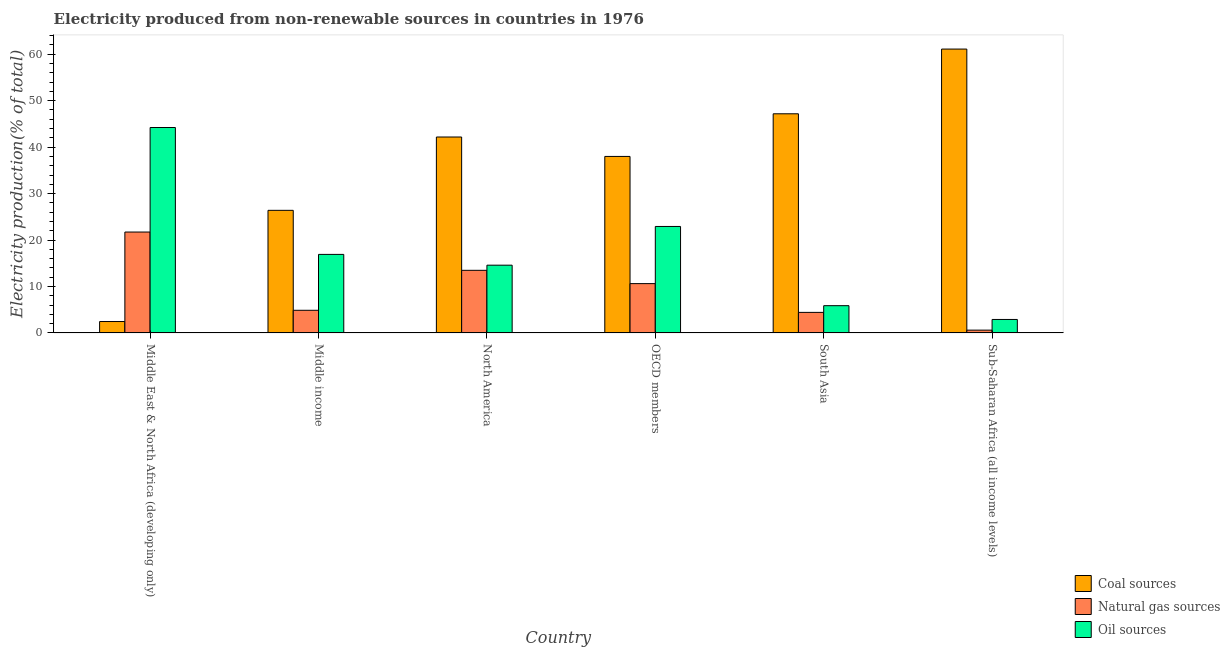How many different coloured bars are there?
Make the answer very short. 3. Are the number of bars on each tick of the X-axis equal?
Give a very brief answer. Yes. How many bars are there on the 5th tick from the right?
Your answer should be very brief. 3. What is the label of the 1st group of bars from the left?
Give a very brief answer. Middle East & North Africa (developing only). What is the percentage of electricity produced by coal in Middle East & North Africa (developing only)?
Give a very brief answer. 2.46. Across all countries, what is the maximum percentage of electricity produced by oil sources?
Your answer should be very brief. 44.23. Across all countries, what is the minimum percentage of electricity produced by natural gas?
Offer a terse response. 0.6. In which country was the percentage of electricity produced by natural gas maximum?
Ensure brevity in your answer.  Middle East & North Africa (developing only). In which country was the percentage of electricity produced by oil sources minimum?
Ensure brevity in your answer.  Sub-Saharan Africa (all income levels). What is the total percentage of electricity produced by oil sources in the graph?
Your answer should be compact. 107.42. What is the difference between the percentage of electricity produced by natural gas in OECD members and that in Sub-Saharan Africa (all income levels)?
Offer a very short reply. 10.01. What is the difference between the percentage of electricity produced by coal in South Asia and the percentage of electricity produced by natural gas in North America?
Provide a short and direct response. 33.7. What is the average percentage of electricity produced by oil sources per country?
Provide a succinct answer. 17.9. What is the difference between the percentage of electricity produced by oil sources and percentage of electricity produced by natural gas in South Asia?
Offer a terse response. 1.44. In how many countries, is the percentage of electricity produced by coal greater than 50 %?
Offer a very short reply. 1. What is the ratio of the percentage of electricity produced by coal in OECD members to that in Sub-Saharan Africa (all income levels)?
Make the answer very short. 0.62. Is the difference between the percentage of electricity produced by coal in North America and OECD members greater than the difference between the percentage of electricity produced by natural gas in North America and OECD members?
Your answer should be very brief. Yes. What is the difference between the highest and the second highest percentage of electricity produced by natural gas?
Your answer should be very brief. 8.24. What is the difference between the highest and the lowest percentage of electricity produced by natural gas?
Your response must be concise. 21.12. In how many countries, is the percentage of electricity produced by oil sources greater than the average percentage of electricity produced by oil sources taken over all countries?
Keep it short and to the point. 2. What does the 1st bar from the left in Sub-Saharan Africa (all income levels) represents?
Your answer should be very brief. Coal sources. What does the 1st bar from the right in North America represents?
Offer a very short reply. Oil sources. Is it the case that in every country, the sum of the percentage of electricity produced by coal and percentage of electricity produced by natural gas is greater than the percentage of electricity produced by oil sources?
Your answer should be compact. No. How many bars are there?
Offer a terse response. 18. What is the difference between two consecutive major ticks on the Y-axis?
Your answer should be very brief. 10. Are the values on the major ticks of Y-axis written in scientific E-notation?
Offer a terse response. No. Does the graph contain grids?
Your response must be concise. No. Where does the legend appear in the graph?
Give a very brief answer. Bottom right. What is the title of the graph?
Offer a terse response. Electricity produced from non-renewable sources in countries in 1976. What is the label or title of the X-axis?
Your response must be concise. Country. What is the Electricity production(% of total) of Coal sources in Middle East & North Africa (developing only)?
Your answer should be very brief. 2.46. What is the Electricity production(% of total) in Natural gas sources in Middle East & North Africa (developing only)?
Give a very brief answer. 21.72. What is the Electricity production(% of total) of Oil sources in Middle East & North Africa (developing only)?
Your answer should be very brief. 44.23. What is the Electricity production(% of total) of Coal sources in Middle income?
Keep it short and to the point. 26.39. What is the Electricity production(% of total) of Natural gas sources in Middle income?
Your response must be concise. 4.87. What is the Electricity production(% of total) in Oil sources in Middle income?
Your response must be concise. 16.91. What is the Electricity production(% of total) in Coal sources in North America?
Offer a very short reply. 42.18. What is the Electricity production(% of total) in Natural gas sources in North America?
Your answer should be very brief. 13.48. What is the Electricity production(% of total) of Oil sources in North America?
Offer a very short reply. 14.59. What is the Electricity production(% of total) of Coal sources in OECD members?
Keep it short and to the point. 38. What is the Electricity production(% of total) in Natural gas sources in OECD members?
Make the answer very short. 10.62. What is the Electricity production(% of total) of Oil sources in OECD members?
Your response must be concise. 22.92. What is the Electricity production(% of total) in Coal sources in South Asia?
Your answer should be very brief. 47.18. What is the Electricity production(% of total) in Natural gas sources in South Asia?
Provide a short and direct response. 4.43. What is the Electricity production(% of total) of Oil sources in South Asia?
Your answer should be compact. 5.87. What is the Electricity production(% of total) of Coal sources in Sub-Saharan Africa (all income levels)?
Your answer should be very brief. 61.11. What is the Electricity production(% of total) in Natural gas sources in Sub-Saharan Africa (all income levels)?
Offer a very short reply. 0.6. What is the Electricity production(% of total) in Oil sources in Sub-Saharan Africa (all income levels)?
Provide a short and direct response. 2.9. Across all countries, what is the maximum Electricity production(% of total) of Coal sources?
Offer a terse response. 61.11. Across all countries, what is the maximum Electricity production(% of total) of Natural gas sources?
Provide a succinct answer. 21.72. Across all countries, what is the maximum Electricity production(% of total) in Oil sources?
Ensure brevity in your answer.  44.23. Across all countries, what is the minimum Electricity production(% of total) in Coal sources?
Provide a short and direct response. 2.46. Across all countries, what is the minimum Electricity production(% of total) in Natural gas sources?
Offer a terse response. 0.6. Across all countries, what is the minimum Electricity production(% of total) of Oil sources?
Provide a short and direct response. 2.9. What is the total Electricity production(% of total) of Coal sources in the graph?
Offer a terse response. 217.32. What is the total Electricity production(% of total) of Natural gas sources in the graph?
Provide a succinct answer. 55.72. What is the total Electricity production(% of total) in Oil sources in the graph?
Your response must be concise. 107.42. What is the difference between the Electricity production(% of total) of Coal sources in Middle East & North Africa (developing only) and that in Middle income?
Ensure brevity in your answer.  -23.94. What is the difference between the Electricity production(% of total) of Natural gas sources in Middle East & North Africa (developing only) and that in Middle income?
Keep it short and to the point. 16.85. What is the difference between the Electricity production(% of total) in Oil sources in Middle East & North Africa (developing only) and that in Middle income?
Keep it short and to the point. 27.32. What is the difference between the Electricity production(% of total) of Coal sources in Middle East & North Africa (developing only) and that in North America?
Keep it short and to the point. -39.72. What is the difference between the Electricity production(% of total) in Natural gas sources in Middle East & North Africa (developing only) and that in North America?
Give a very brief answer. 8.24. What is the difference between the Electricity production(% of total) in Oil sources in Middle East & North Africa (developing only) and that in North America?
Offer a terse response. 29.64. What is the difference between the Electricity production(% of total) in Coal sources in Middle East & North Africa (developing only) and that in OECD members?
Offer a terse response. -35.54. What is the difference between the Electricity production(% of total) in Natural gas sources in Middle East & North Africa (developing only) and that in OECD members?
Make the answer very short. 11.1. What is the difference between the Electricity production(% of total) in Oil sources in Middle East & North Africa (developing only) and that in OECD members?
Your answer should be very brief. 21.3. What is the difference between the Electricity production(% of total) of Coal sources in Middle East & North Africa (developing only) and that in South Asia?
Offer a terse response. -44.72. What is the difference between the Electricity production(% of total) of Natural gas sources in Middle East & North Africa (developing only) and that in South Asia?
Your answer should be very brief. 17.3. What is the difference between the Electricity production(% of total) of Oil sources in Middle East & North Africa (developing only) and that in South Asia?
Your answer should be very brief. 38.36. What is the difference between the Electricity production(% of total) of Coal sources in Middle East & North Africa (developing only) and that in Sub-Saharan Africa (all income levels)?
Keep it short and to the point. -58.65. What is the difference between the Electricity production(% of total) in Natural gas sources in Middle East & North Africa (developing only) and that in Sub-Saharan Africa (all income levels)?
Provide a short and direct response. 21.12. What is the difference between the Electricity production(% of total) of Oil sources in Middle East & North Africa (developing only) and that in Sub-Saharan Africa (all income levels)?
Offer a terse response. 41.32. What is the difference between the Electricity production(% of total) in Coal sources in Middle income and that in North America?
Your answer should be compact. -15.79. What is the difference between the Electricity production(% of total) in Natural gas sources in Middle income and that in North America?
Your response must be concise. -8.61. What is the difference between the Electricity production(% of total) of Oil sources in Middle income and that in North America?
Ensure brevity in your answer.  2.32. What is the difference between the Electricity production(% of total) of Coal sources in Middle income and that in OECD members?
Provide a short and direct response. -11.6. What is the difference between the Electricity production(% of total) of Natural gas sources in Middle income and that in OECD members?
Provide a short and direct response. -5.74. What is the difference between the Electricity production(% of total) of Oil sources in Middle income and that in OECD members?
Your response must be concise. -6.01. What is the difference between the Electricity production(% of total) of Coal sources in Middle income and that in South Asia?
Offer a very short reply. -20.78. What is the difference between the Electricity production(% of total) in Natural gas sources in Middle income and that in South Asia?
Provide a short and direct response. 0.45. What is the difference between the Electricity production(% of total) of Oil sources in Middle income and that in South Asia?
Offer a terse response. 11.04. What is the difference between the Electricity production(% of total) in Coal sources in Middle income and that in Sub-Saharan Africa (all income levels)?
Give a very brief answer. -34.72. What is the difference between the Electricity production(% of total) of Natural gas sources in Middle income and that in Sub-Saharan Africa (all income levels)?
Offer a terse response. 4.27. What is the difference between the Electricity production(% of total) in Oil sources in Middle income and that in Sub-Saharan Africa (all income levels)?
Keep it short and to the point. 14.01. What is the difference between the Electricity production(% of total) in Coal sources in North America and that in OECD members?
Your response must be concise. 4.18. What is the difference between the Electricity production(% of total) in Natural gas sources in North America and that in OECD members?
Your response must be concise. 2.86. What is the difference between the Electricity production(% of total) in Oil sources in North America and that in OECD members?
Your answer should be very brief. -8.33. What is the difference between the Electricity production(% of total) in Coal sources in North America and that in South Asia?
Provide a short and direct response. -5. What is the difference between the Electricity production(% of total) of Natural gas sources in North America and that in South Asia?
Your response must be concise. 9.06. What is the difference between the Electricity production(% of total) in Oil sources in North America and that in South Asia?
Offer a very short reply. 8.72. What is the difference between the Electricity production(% of total) in Coal sources in North America and that in Sub-Saharan Africa (all income levels)?
Provide a succinct answer. -18.93. What is the difference between the Electricity production(% of total) of Natural gas sources in North America and that in Sub-Saharan Africa (all income levels)?
Your answer should be very brief. 12.88. What is the difference between the Electricity production(% of total) in Oil sources in North America and that in Sub-Saharan Africa (all income levels)?
Provide a succinct answer. 11.69. What is the difference between the Electricity production(% of total) of Coal sources in OECD members and that in South Asia?
Keep it short and to the point. -9.18. What is the difference between the Electricity production(% of total) of Natural gas sources in OECD members and that in South Asia?
Offer a terse response. 6.19. What is the difference between the Electricity production(% of total) of Oil sources in OECD members and that in South Asia?
Ensure brevity in your answer.  17.05. What is the difference between the Electricity production(% of total) of Coal sources in OECD members and that in Sub-Saharan Africa (all income levels)?
Offer a terse response. -23.11. What is the difference between the Electricity production(% of total) in Natural gas sources in OECD members and that in Sub-Saharan Africa (all income levels)?
Make the answer very short. 10.01. What is the difference between the Electricity production(% of total) of Oil sources in OECD members and that in Sub-Saharan Africa (all income levels)?
Provide a succinct answer. 20.02. What is the difference between the Electricity production(% of total) in Coal sources in South Asia and that in Sub-Saharan Africa (all income levels)?
Keep it short and to the point. -13.93. What is the difference between the Electricity production(% of total) of Natural gas sources in South Asia and that in Sub-Saharan Africa (all income levels)?
Your answer should be very brief. 3.82. What is the difference between the Electricity production(% of total) of Oil sources in South Asia and that in Sub-Saharan Africa (all income levels)?
Offer a very short reply. 2.97. What is the difference between the Electricity production(% of total) of Coal sources in Middle East & North Africa (developing only) and the Electricity production(% of total) of Natural gas sources in Middle income?
Provide a short and direct response. -2.42. What is the difference between the Electricity production(% of total) in Coal sources in Middle East & North Africa (developing only) and the Electricity production(% of total) in Oil sources in Middle income?
Your response must be concise. -14.45. What is the difference between the Electricity production(% of total) of Natural gas sources in Middle East & North Africa (developing only) and the Electricity production(% of total) of Oil sources in Middle income?
Your response must be concise. 4.81. What is the difference between the Electricity production(% of total) in Coal sources in Middle East & North Africa (developing only) and the Electricity production(% of total) in Natural gas sources in North America?
Your response must be concise. -11.02. What is the difference between the Electricity production(% of total) of Coal sources in Middle East & North Africa (developing only) and the Electricity production(% of total) of Oil sources in North America?
Provide a short and direct response. -12.13. What is the difference between the Electricity production(% of total) in Natural gas sources in Middle East & North Africa (developing only) and the Electricity production(% of total) in Oil sources in North America?
Provide a short and direct response. 7.13. What is the difference between the Electricity production(% of total) in Coal sources in Middle East & North Africa (developing only) and the Electricity production(% of total) in Natural gas sources in OECD members?
Offer a terse response. -8.16. What is the difference between the Electricity production(% of total) in Coal sources in Middle East & North Africa (developing only) and the Electricity production(% of total) in Oil sources in OECD members?
Your response must be concise. -20.47. What is the difference between the Electricity production(% of total) of Natural gas sources in Middle East & North Africa (developing only) and the Electricity production(% of total) of Oil sources in OECD members?
Your answer should be very brief. -1.2. What is the difference between the Electricity production(% of total) in Coal sources in Middle East & North Africa (developing only) and the Electricity production(% of total) in Natural gas sources in South Asia?
Provide a succinct answer. -1.97. What is the difference between the Electricity production(% of total) of Coal sources in Middle East & North Africa (developing only) and the Electricity production(% of total) of Oil sources in South Asia?
Your answer should be very brief. -3.41. What is the difference between the Electricity production(% of total) of Natural gas sources in Middle East & North Africa (developing only) and the Electricity production(% of total) of Oil sources in South Asia?
Your response must be concise. 15.85. What is the difference between the Electricity production(% of total) of Coal sources in Middle East & North Africa (developing only) and the Electricity production(% of total) of Natural gas sources in Sub-Saharan Africa (all income levels)?
Ensure brevity in your answer.  1.85. What is the difference between the Electricity production(% of total) of Coal sources in Middle East & North Africa (developing only) and the Electricity production(% of total) of Oil sources in Sub-Saharan Africa (all income levels)?
Offer a terse response. -0.45. What is the difference between the Electricity production(% of total) of Natural gas sources in Middle East & North Africa (developing only) and the Electricity production(% of total) of Oil sources in Sub-Saharan Africa (all income levels)?
Your response must be concise. 18.82. What is the difference between the Electricity production(% of total) of Coal sources in Middle income and the Electricity production(% of total) of Natural gas sources in North America?
Make the answer very short. 12.91. What is the difference between the Electricity production(% of total) of Coal sources in Middle income and the Electricity production(% of total) of Oil sources in North America?
Keep it short and to the point. 11.81. What is the difference between the Electricity production(% of total) in Natural gas sources in Middle income and the Electricity production(% of total) in Oil sources in North America?
Provide a succinct answer. -9.71. What is the difference between the Electricity production(% of total) in Coal sources in Middle income and the Electricity production(% of total) in Natural gas sources in OECD members?
Provide a succinct answer. 15.78. What is the difference between the Electricity production(% of total) of Coal sources in Middle income and the Electricity production(% of total) of Oil sources in OECD members?
Provide a succinct answer. 3.47. What is the difference between the Electricity production(% of total) in Natural gas sources in Middle income and the Electricity production(% of total) in Oil sources in OECD members?
Offer a very short reply. -18.05. What is the difference between the Electricity production(% of total) of Coal sources in Middle income and the Electricity production(% of total) of Natural gas sources in South Asia?
Give a very brief answer. 21.97. What is the difference between the Electricity production(% of total) of Coal sources in Middle income and the Electricity production(% of total) of Oil sources in South Asia?
Your answer should be compact. 20.53. What is the difference between the Electricity production(% of total) in Natural gas sources in Middle income and the Electricity production(% of total) in Oil sources in South Asia?
Provide a short and direct response. -0.99. What is the difference between the Electricity production(% of total) of Coal sources in Middle income and the Electricity production(% of total) of Natural gas sources in Sub-Saharan Africa (all income levels)?
Provide a short and direct response. 25.79. What is the difference between the Electricity production(% of total) in Coal sources in Middle income and the Electricity production(% of total) in Oil sources in Sub-Saharan Africa (all income levels)?
Keep it short and to the point. 23.49. What is the difference between the Electricity production(% of total) in Natural gas sources in Middle income and the Electricity production(% of total) in Oil sources in Sub-Saharan Africa (all income levels)?
Ensure brevity in your answer.  1.97. What is the difference between the Electricity production(% of total) in Coal sources in North America and the Electricity production(% of total) in Natural gas sources in OECD members?
Provide a succinct answer. 31.56. What is the difference between the Electricity production(% of total) of Coal sources in North America and the Electricity production(% of total) of Oil sources in OECD members?
Offer a terse response. 19.26. What is the difference between the Electricity production(% of total) in Natural gas sources in North America and the Electricity production(% of total) in Oil sources in OECD members?
Provide a succinct answer. -9.44. What is the difference between the Electricity production(% of total) in Coal sources in North America and the Electricity production(% of total) in Natural gas sources in South Asia?
Your response must be concise. 37.76. What is the difference between the Electricity production(% of total) in Coal sources in North America and the Electricity production(% of total) in Oil sources in South Asia?
Offer a very short reply. 36.31. What is the difference between the Electricity production(% of total) of Natural gas sources in North America and the Electricity production(% of total) of Oil sources in South Asia?
Ensure brevity in your answer.  7.61. What is the difference between the Electricity production(% of total) of Coal sources in North America and the Electricity production(% of total) of Natural gas sources in Sub-Saharan Africa (all income levels)?
Make the answer very short. 41.58. What is the difference between the Electricity production(% of total) of Coal sources in North America and the Electricity production(% of total) of Oil sources in Sub-Saharan Africa (all income levels)?
Make the answer very short. 39.28. What is the difference between the Electricity production(% of total) of Natural gas sources in North America and the Electricity production(% of total) of Oil sources in Sub-Saharan Africa (all income levels)?
Offer a terse response. 10.58. What is the difference between the Electricity production(% of total) in Coal sources in OECD members and the Electricity production(% of total) in Natural gas sources in South Asia?
Offer a terse response. 33.57. What is the difference between the Electricity production(% of total) of Coal sources in OECD members and the Electricity production(% of total) of Oil sources in South Asia?
Give a very brief answer. 32.13. What is the difference between the Electricity production(% of total) in Natural gas sources in OECD members and the Electricity production(% of total) in Oil sources in South Asia?
Your answer should be compact. 4.75. What is the difference between the Electricity production(% of total) of Coal sources in OECD members and the Electricity production(% of total) of Natural gas sources in Sub-Saharan Africa (all income levels)?
Your response must be concise. 37.39. What is the difference between the Electricity production(% of total) in Coal sources in OECD members and the Electricity production(% of total) in Oil sources in Sub-Saharan Africa (all income levels)?
Your answer should be compact. 35.09. What is the difference between the Electricity production(% of total) of Natural gas sources in OECD members and the Electricity production(% of total) of Oil sources in Sub-Saharan Africa (all income levels)?
Give a very brief answer. 7.71. What is the difference between the Electricity production(% of total) of Coal sources in South Asia and the Electricity production(% of total) of Natural gas sources in Sub-Saharan Africa (all income levels)?
Make the answer very short. 46.57. What is the difference between the Electricity production(% of total) in Coal sources in South Asia and the Electricity production(% of total) in Oil sources in Sub-Saharan Africa (all income levels)?
Give a very brief answer. 44.27. What is the difference between the Electricity production(% of total) in Natural gas sources in South Asia and the Electricity production(% of total) in Oil sources in Sub-Saharan Africa (all income levels)?
Provide a short and direct response. 1.52. What is the average Electricity production(% of total) in Coal sources per country?
Make the answer very short. 36.22. What is the average Electricity production(% of total) of Natural gas sources per country?
Offer a terse response. 9.29. What is the average Electricity production(% of total) in Oil sources per country?
Your answer should be compact. 17.9. What is the difference between the Electricity production(% of total) in Coal sources and Electricity production(% of total) in Natural gas sources in Middle East & North Africa (developing only)?
Give a very brief answer. -19.26. What is the difference between the Electricity production(% of total) in Coal sources and Electricity production(% of total) in Oil sources in Middle East & North Africa (developing only)?
Offer a very short reply. -41.77. What is the difference between the Electricity production(% of total) in Natural gas sources and Electricity production(% of total) in Oil sources in Middle East & North Africa (developing only)?
Keep it short and to the point. -22.5. What is the difference between the Electricity production(% of total) of Coal sources and Electricity production(% of total) of Natural gas sources in Middle income?
Your answer should be compact. 21.52. What is the difference between the Electricity production(% of total) in Coal sources and Electricity production(% of total) in Oil sources in Middle income?
Give a very brief answer. 9.49. What is the difference between the Electricity production(% of total) of Natural gas sources and Electricity production(% of total) of Oil sources in Middle income?
Keep it short and to the point. -12.03. What is the difference between the Electricity production(% of total) in Coal sources and Electricity production(% of total) in Natural gas sources in North America?
Provide a succinct answer. 28.7. What is the difference between the Electricity production(% of total) in Coal sources and Electricity production(% of total) in Oil sources in North America?
Make the answer very short. 27.59. What is the difference between the Electricity production(% of total) of Natural gas sources and Electricity production(% of total) of Oil sources in North America?
Provide a short and direct response. -1.11. What is the difference between the Electricity production(% of total) in Coal sources and Electricity production(% of total) in Natural gas sources in OECD members?
Offer a very short reply. 27.38. What is the difference between the Electricity production(% of total) in Coal sources and Electricity production(% of total) in Oil sources in OECD members?
Your answer should be compact. 15.07. What is the difference between the Electricity production(% of total) of Natural gas sources and Electricity production(% of total) of Oil sources in OECD members?
Your answer should be very brief. -12.31. What is the difference between the Electricity production(% of total) in Coal sources and Electricity production(% of total) in Natural gas sources in South Asia?
Offer a very short reply. 42.75. What is the difference between the Electricity production(% of total) of Coal sources and Electricity production(% of total) of Oil sources in South Asia?
Provide a succinct answer. 41.31. What is the difference between the Electricity production(% of total) in Natural gas sources and Electricity production(% of total) in Oil sources in South Asia?
Your answer should be compact. -1.44. What is the difference between the Electricity production(% of total) of Coal sources and Electricity production(% of total) of Natural gas sources in Sub-Saharan Africa (all income levels)?
Your answer should be very brief. 60.51. What is the difference between the Electricity production(% of total) of Coal sources and Electricity production(% of total) of Oil sources in Sub-Saharan Africa (all income levels)?
Give a very brief answer. 58.21. What is the difference between the Electricity production(% of total) of Natural gas sources and Electricity production(% of total) of Oil sources in Sub-Saharan Africa (all income levels)?
Your answer should be compact. -2.3. What is the ratio of the Electricity production(% of total) of Coal sources in Middle East & North Africa (developing only) to that in Middle income?
Your response must be concise. 0.09. What is the ratio of the Electricity production(% of total) in Natural gas sources in Middle East & North Africa (developing only) to that in Middle income?
Your answer should be compact. 4.46. What is the ratio of the Electricity production(% of total) of Oil sources in Middle East & North Africa (developing only) to that in Middle income?
Your response must be concise. 2.62. What is the ratio of the Electricity production(% of total) of Coal sources in Middle East & North Africa (developing only) to that in North America?
Ensure brevity in your answer.  0.06. What is the ratio of the Electricity production(% of total) in Natural gas sources in Middle East & North Africa (developing only) to that in North America?
Your response must be concise. 1.61. What is the ratio of the Electricity production(% of total) in Oil sources in Middle East & North Africa (developing only) to that in North America?
Your answer should be compact. 3.03. What is the ratio of the Electricity production(% of total) of Coal sources in Middle East & North Africa (developing only) to that in OECD members?
Make the answer very short. 0.06. What is the ratio of the Electricity production(% of total) in Natural gas sources in Middle East & North Africa (developing only) to that in OECD members?
Provide a short and direct response. 2.05. What is the ratio of the Electricity production(% of total) in Oil sources in Middle East & North Africa (developing only) to that in OECD members?
Give a very brief answer. 1.93. What is the ratio of the Electricity production(% of total) of Coal sources in Middle East & North Africa (developing only) to that in South Asia?
Your answer should be compact. 0.05. What is the ratio of the Electricity production(% of total) in Natural gas sources in Middle East & North Africa (developing only) to that in South Asia?
Keep it short and to the point. 4.91. What is the ratio of the Electricity production(% of total) of Oil sources in Middle East & North Africa (developing only) to that in South Asia?
Offer a terse response. 7.54. What is the ratio of the Electricity production(% of total) of Coal sources in Middle East & North Africa (developing only) to that in Sub-Saharan Africa (all income levels)?
Keep it short and to the point. 0.04. What is the ratio of the Electricity production(% of total) of Natural gas sources in Middle East & North Africa (developing only) to that in Sub-Saharan Africa (all income levels)?
Your answer should be very brief. 35.92. What is the ratio of the Electricity production(% of total) of Oil sources in Middle East & North Africa (developing only) to that in Sub-Saharan Africa (all income levels)?
Your response must be concise. 15.23. What is the ratio of the Electricity production(% of total) in Coal sources in Middle income to that in North America?
Your answer should be compact. 0.63. What is the ratio of the Electricity production(% of total) of Natural gas sources in Middle income to that in North America?
Your answer should be very brief. 0.36. What is the ratio of the Electricity production(% of total) of Oil sources in Middle income to that in North America?
Ensure brevity in your answer.  1.16. What is the ratio of the Electricity production(% of total) of Coal sources in Middle income to that in OECD members?
Provide a short and direct response. 0.69. What is the ratio of the Electricity production(% of total) of Natural gas sources in Middle income to that in OECD members?
Provide a succinct answer. 0.46. What is the ratio of the Electricity production(% of total) in Oil sources in Middle income to that in OECD members?
Keep it short and to the point. 0.74. What is the ratio of the Electricity production(% of total) of Coal sources in Middle income to that in South Asia?
Offer a very short reply. 0.56. What is the ratio of the Electricity production(% of total) of Natural gas sources in Middle income to that in South Asia?
Your answer should be compact. 1.1. What is the ratio of the Electricity production(% of total) in Oil sources in Middle income to that in South Asia?
Provide a succinct answer. 2.88. What is the ratio of the Electricity production(% of total) of Coal sources in Middle income to that in Sub-Saharan Africa (all income levels)?
Offer a terse response. 0.43. What is the ratio of the Electricity production(% of total) in Natural gas sources in Middle income to that in Sub-Saharan Africa (all income levels)?
Your answer should be compact. 8.06. What is the ratio of the Electricity production(% of total) of Oil sources in Middle income to that in Sub-Saharan Africa (all income levels)?
Offer a terse response. 5.82. What is the ratio of the Electricity production(% of total) in Coal sources in North America to that in OECD members?
Your answer should be compact. 1.11. What is the ratio of the Electricity production(% of total) of Natural gas sources in North America to that in OECD members?
Provide a succinct answer. 1.27. What is the ratio of the Electricity production(% of total) in Oil sources in North America to that in OECD members?
Make the answer very short. 0.64. What is the ratio of the Electricity production(% of total) in Coal sources in North America to that in South Asia?
Ensure brevity in your answer.  0.89. What is the ratio of the Electricity production(% of total) in Natural gas sources in North America to that in South Asia?
Provide a succinct answer. 3.05. What is the ratio of the Electricity production(% of total) of Oil sources in North America to that in South Asia?
Your answer should be very brief. 2.49. What is the ratio of the Electricity production(% of total) in Coal sources in North America to that in Sub-Saharan Africa (all income levels)?
Offer a very short reply. 0.69. What is the ratio of the Electricity production(% of total) in Natural gas sources in North America to that in Sub-Saharan Africa (all income levels)?
Your answer should be very brief. 22.29. What is the ratio of the Electricity production(% of total) in Oil sources in North America to that in Sub-Saharan Africa (all income levels)?
Your response must be concise. 5.03. What is the ratio of the Electricity production(% of total) of Coal sources in OECD members to that in South Asia?
Provide a short and direct response. 0.81. What is the ratio of the Electricity production(% of total) in Natural gas sources in OECD members to that in South Asia?
Keep it short and to the point. 2.4. What is the ratio of the Electricity production(% of total) of Oil sources in OECD members to that in South Asia?
Keep it short and to the point. 3.91. What is the ratio of the Electricity production(% of total) of Coal sources in OECD members to that in Sub-Saharan Africa (all income levels)?
Offer a very short reply. 0.62. What is the ratio of the Electricity production(% of total) in Natural gas sources in OECD members to that in Sub-Saharan Africa (all income levels)?
Your answer should be compact. 17.56. What is the ratio of the Electricity production(% of total) in Oil sources in OECD members to that in Sub-Saharan Africa (all income levels)?
Offer a terse response. 7.9. What is the ratio of the Electricity production(% of total) in Coal sources in South Asia to that in Sub-Saharan Africa (all income levels)?
Your answer should be compact. 0.77. What is the ratio of the Electricity production(% of total) of Natural gas sources in South Asia to that in Sub-Saharan Africa (all income levels)?
Give a very brief answer. 7.32. What is the ratio of the Electricity production(% of total) in Oil sources in South Asia to that in Sub-Saharan Africa (all income levels)?
Provide a short and direct response. 2.02. What is the difference between the highest and the second highest Electricity production(% of total) in Coal sources?
Offer a terse response. 13.93. What is the difference between the highest and the second highest Electricity production(% of total) of Natural gas sources?
Provide a succinct answer. 8.24. What is the difference between the highest and the second highest Electricity production(% of total) in Oil sources?
Your response must be concise. 21.3. What is the difference between the highest and the lowest Electricity production(% of total) of Coal sources?
Provide a succinct answer. 58.65. What is the difference between the highest and the lowest Electricity production(% of total) in Natural gas sources?
Make the answer very short. 21.12. What is the difference between the highest and the lowest Electricity production(% of total) in Oil sources?
Keep it short and to the point. 41.32. 